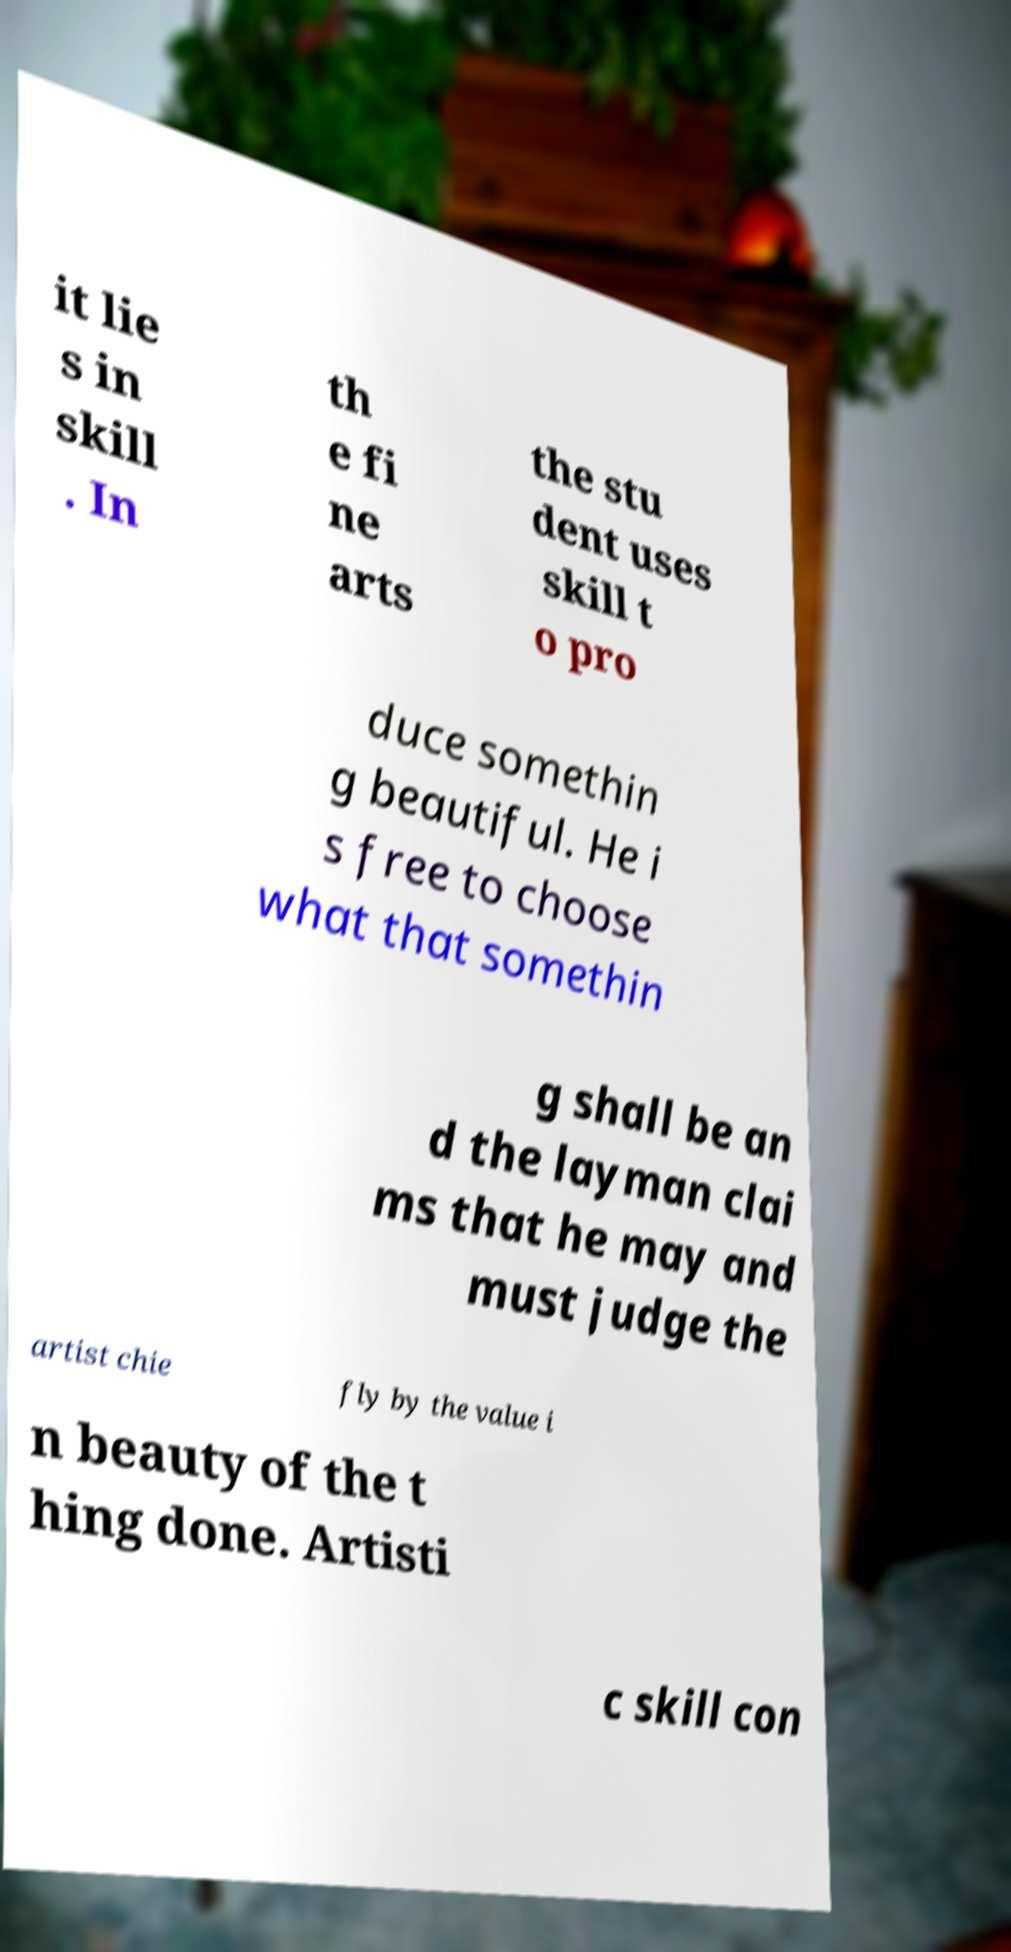Please identify and transcribe the text found in this image. it lie s in skill . In th e fi ne arts the stu dent uses skill t o pro duce somethin g beautiful. He i s free to choose what that somethin g shall be an d the layman clai ms that he may and must judge the artist chie fly by the value i n beauty of the t hing done. Artisti c skill con 